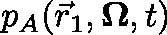<formula> <loc_0><loc_0><loc_500><loc_500>p _ { A } ( \ V e c { r } _ { 1 } , \Omega , t )</formula> 